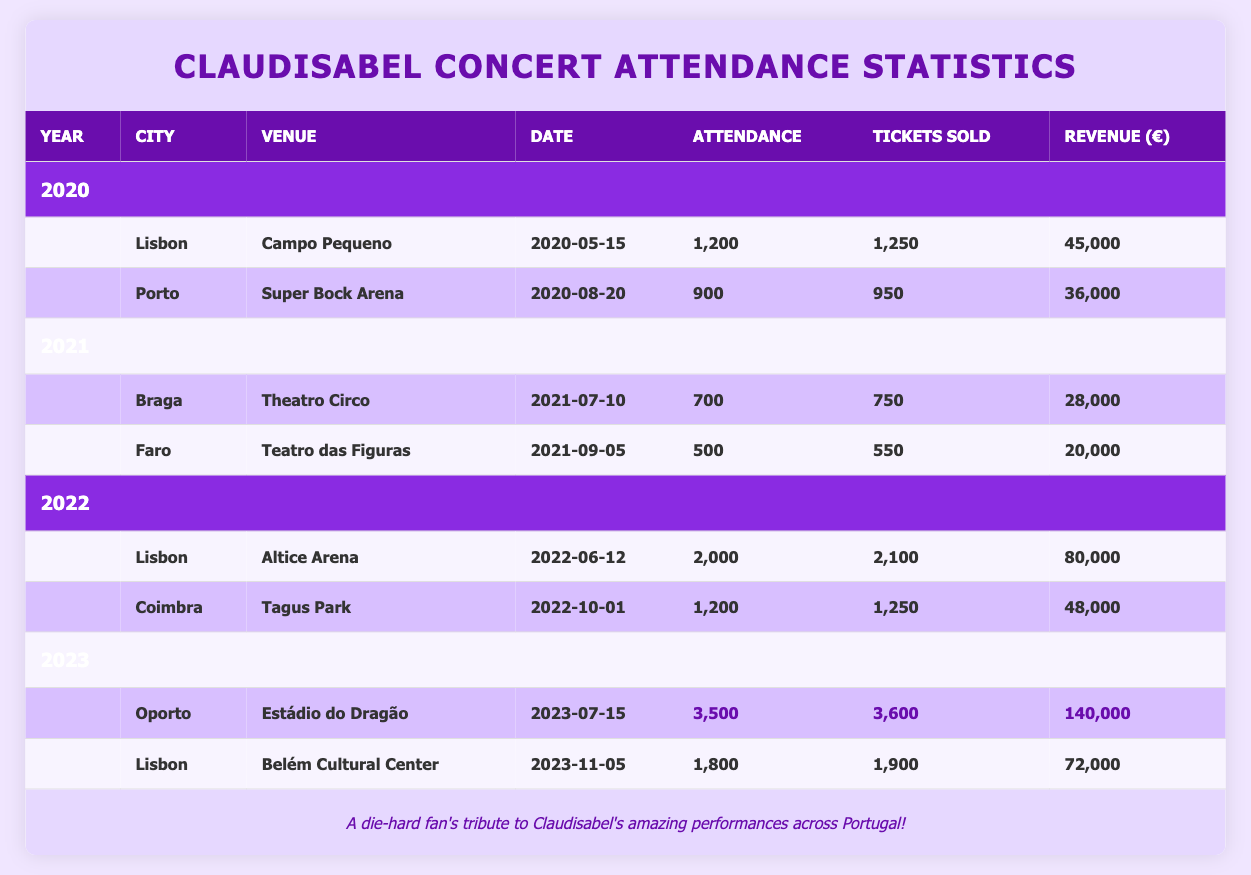What was the total attendance for Claudisabel's concerts in 2020? The attendance for Lisbon is 1,200 and for Porto is 900. Adding these figures together: 1,200 + 900 = 2,100.
Answer: 2,100 Which city had the highest attendance for a Claudisabel concert in 2023? In 2023, Oporto had an attendance of 3,500 while Lisbon had 1,800. Therefore, Oporto had the highest attendance.
Answer: Oporto Was the revenue generated from the concert in Coimbra higher than the concert in Braga? The revenue from Coimbra is 48,000 and from Braga is 28,000. Since 48,000 is higher than 28,000, the statement is true.
Answer: Yes What is the difference in tickets sold between the concert in Lisbon in 2022 and the concert in Faro in 2021? In Lisbon in 2022, tickets sold were 2,100. In Faro in 2021, tickets sold were 550. The difference is calculated as 2,100 - 550 = 1,550.
Answer: 1,550 How much revenue was generated in total across all concerts in 2022? The revenue from the Lisbon concert is 80,000 and from Coimbra is 48,000. Adding these gives: 80,000 + 48,000 = 128,000.
Answer: 128,000 Did Claudisabel perform in a venue named "Teatro das Figuras"? Yes, this venue is listed for the concert in Faro in 2021.
Answer: Yes What is the average attendance across all concerts in 2021? The attendance in 2021 includes Braga with 700 and Faro with 500. To find the average: (700 + 500) / 2 = 600.
Answer: 600 Which concert generated the highest revenue, and how much was it? In 2023, the concert in Oporto generated the highest revenue of 140,000.
Answer: 140,000 How many tickets were sold in total for Claudisabel's concerts in 2020? In 2020, Lisbon sold 1,250 tickets and Porto sold 950 tickets. Adding these gives: 1,250 + 950 = 2,200.
Answer: 2,200 